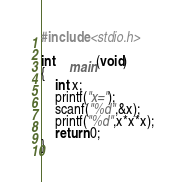<code> <loc_0><loc_0><loc_500><loc_500><_C_>#include <stdio.h>

int	main(void)
{
	int x;
	printf("x=");
	scanf("%d",&x);
	printf("%d",x*x*x);
	return 0;
}</code> 